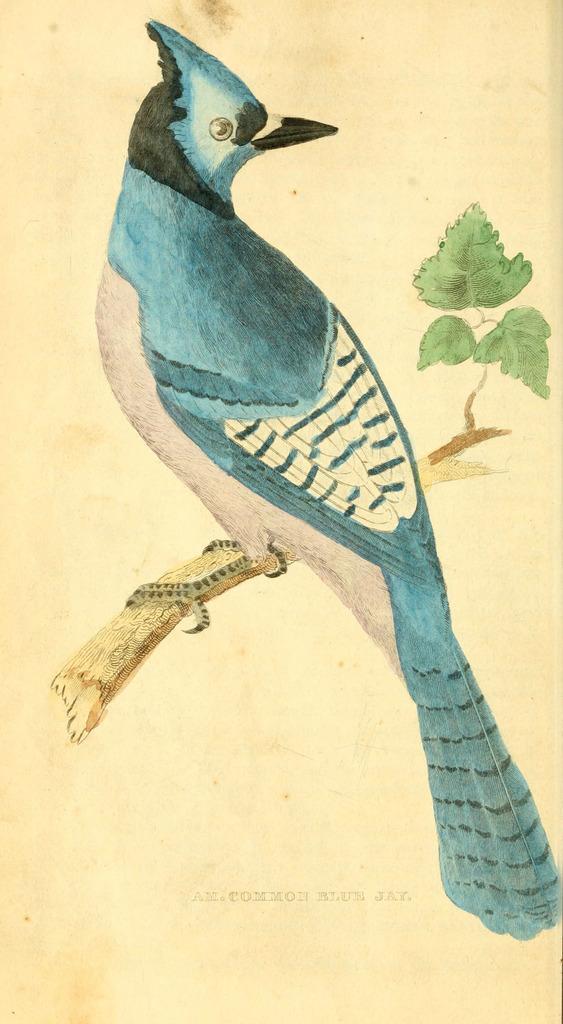Can you describe this image briefly? In this image there is a painting of a bird which is sitting on the tree stem. 